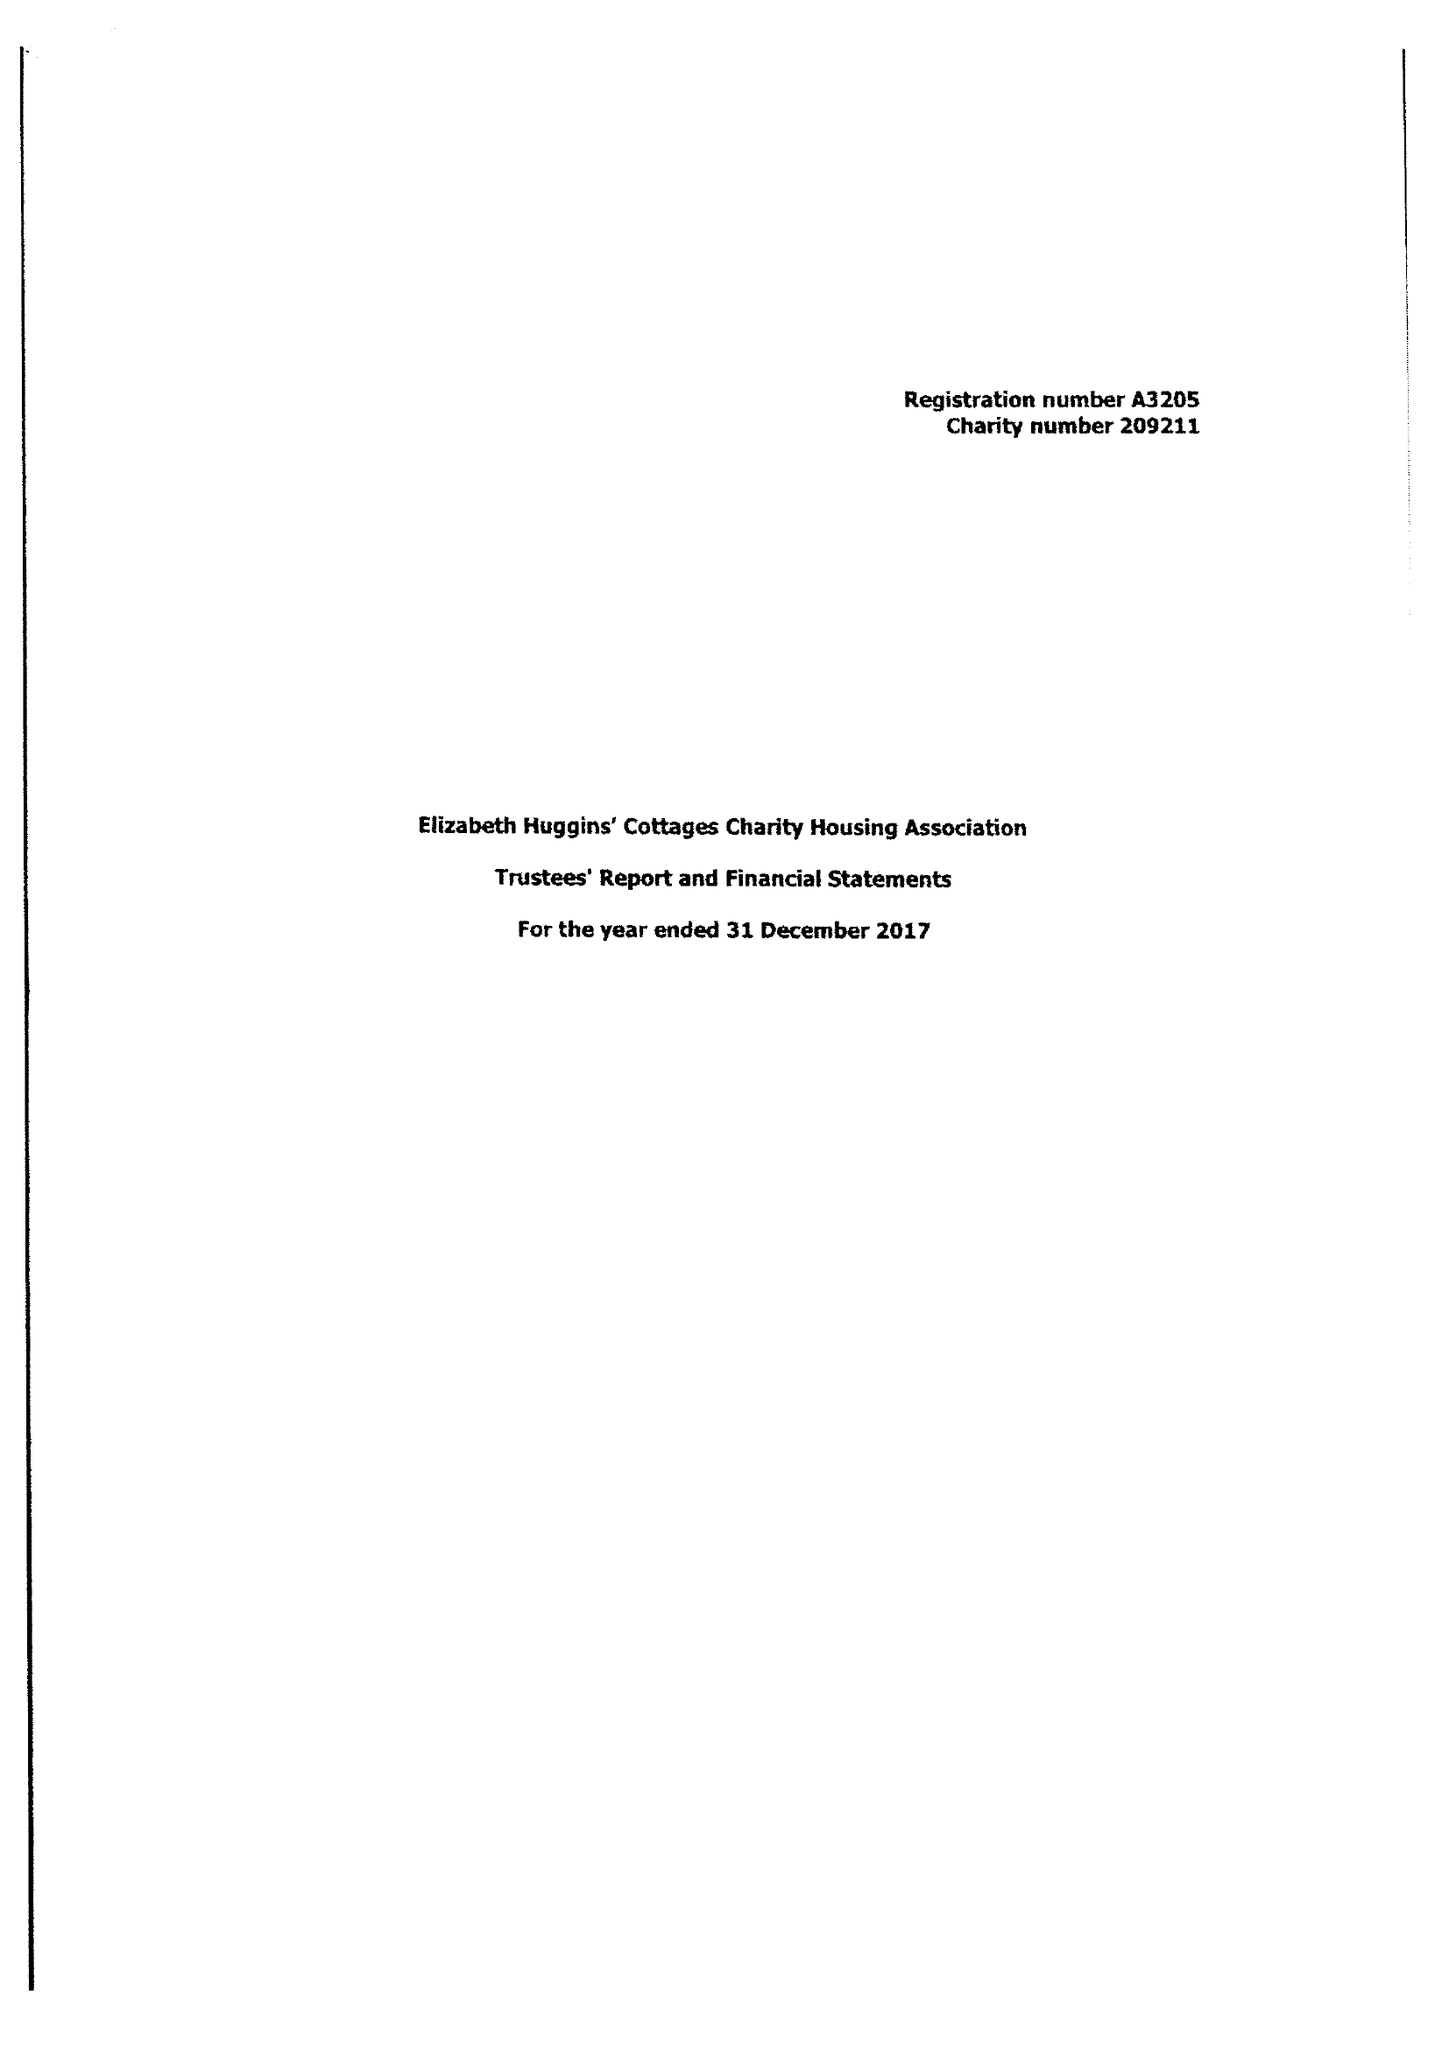What is the value for the address__street_line?
Answer the question using a single word or phrase. 14 LONDON ROAD 